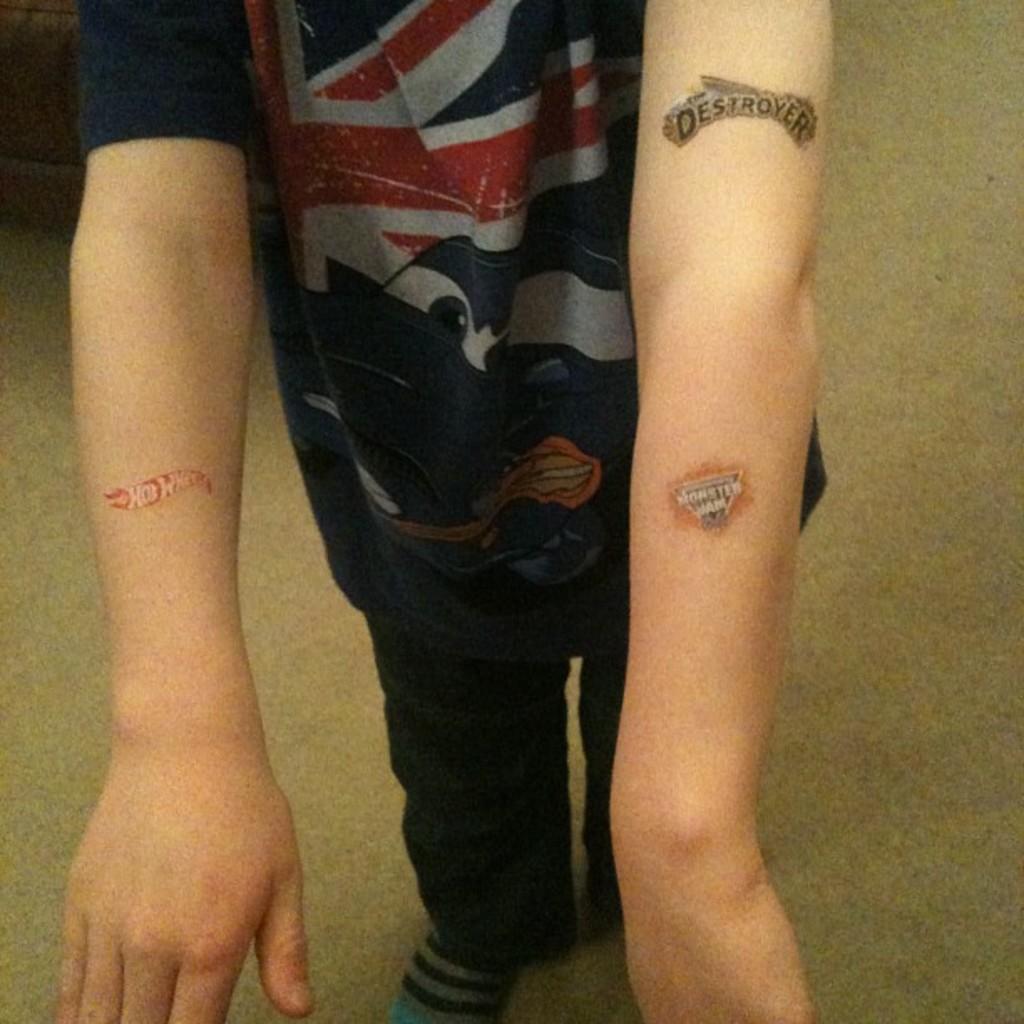What do his tattoos say?
Your answer should be compact. Unanswerable. What does the tattoo on his upper arm say?
Ensure brevity in your answer.  Destroyer. 